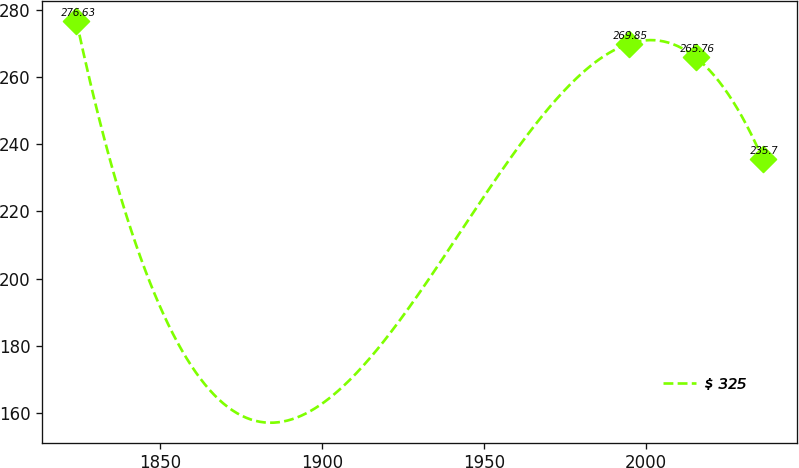<chart> <loc_0><loc_0><loc_500><loc_500><line_chart><ecel><fcel>$ 325<nl><fcel>1824.1<fcel>276.63<nl><fcel>1994.73<fcel>269.85<nl><fcel>2015.32<fcel>265.76<nl><fcel>2035.91<fcel>235.7<nl></chart> 